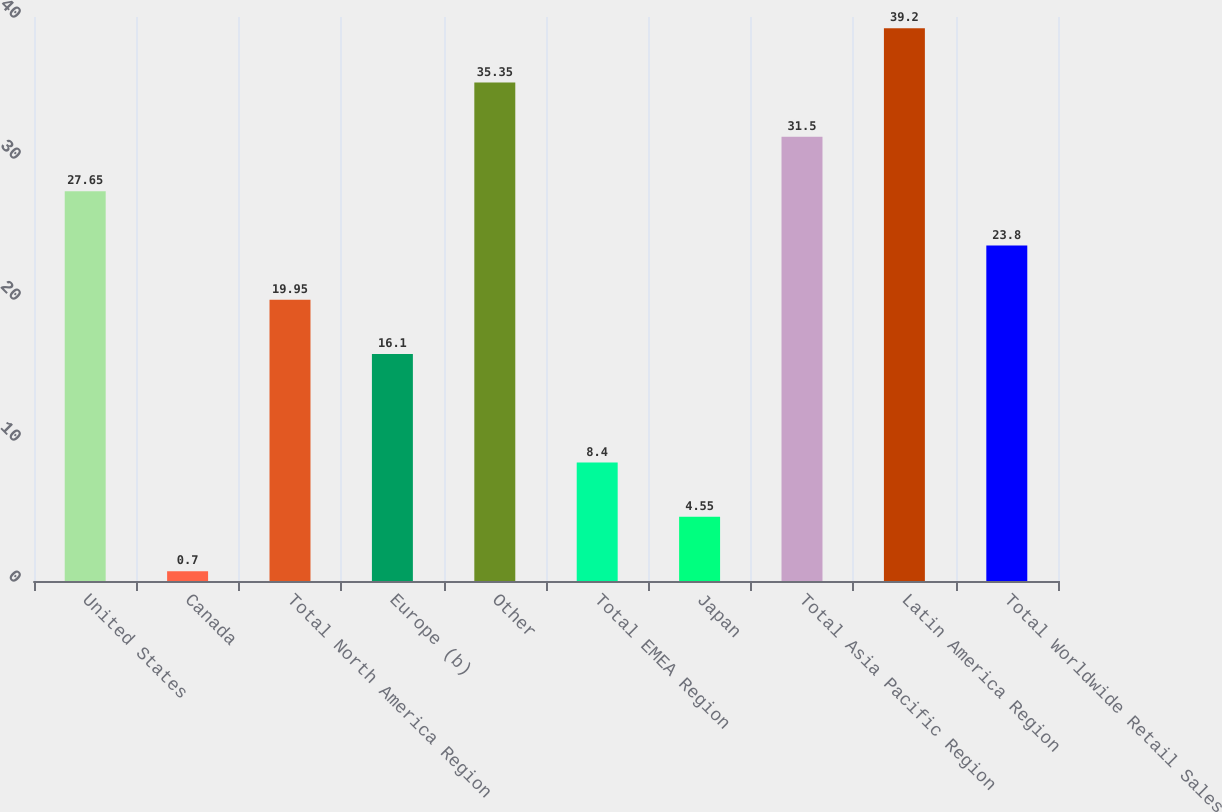<chart> <loc_0><loc_0><loc_500><loc_500><bar_chart><fcel>United States<fcel>Canada<fcel>Total North America Region<fcel>Europe (b)<fcel>Other<fcel>Total EMEA Region<fcel>Japan<fcel>Total Asia Pacific Region<fcel>Latin America Region<fcel>Total Worldwide Retail Sales<nl><fcel>27.65<fcel>0.7<fcel>19.95<fcel>16.1<fcel>35.35<fcel>8.4<fcel>4.55<fcel>31.5<fcel>39.2<fcel>23.8<nl></chart> 